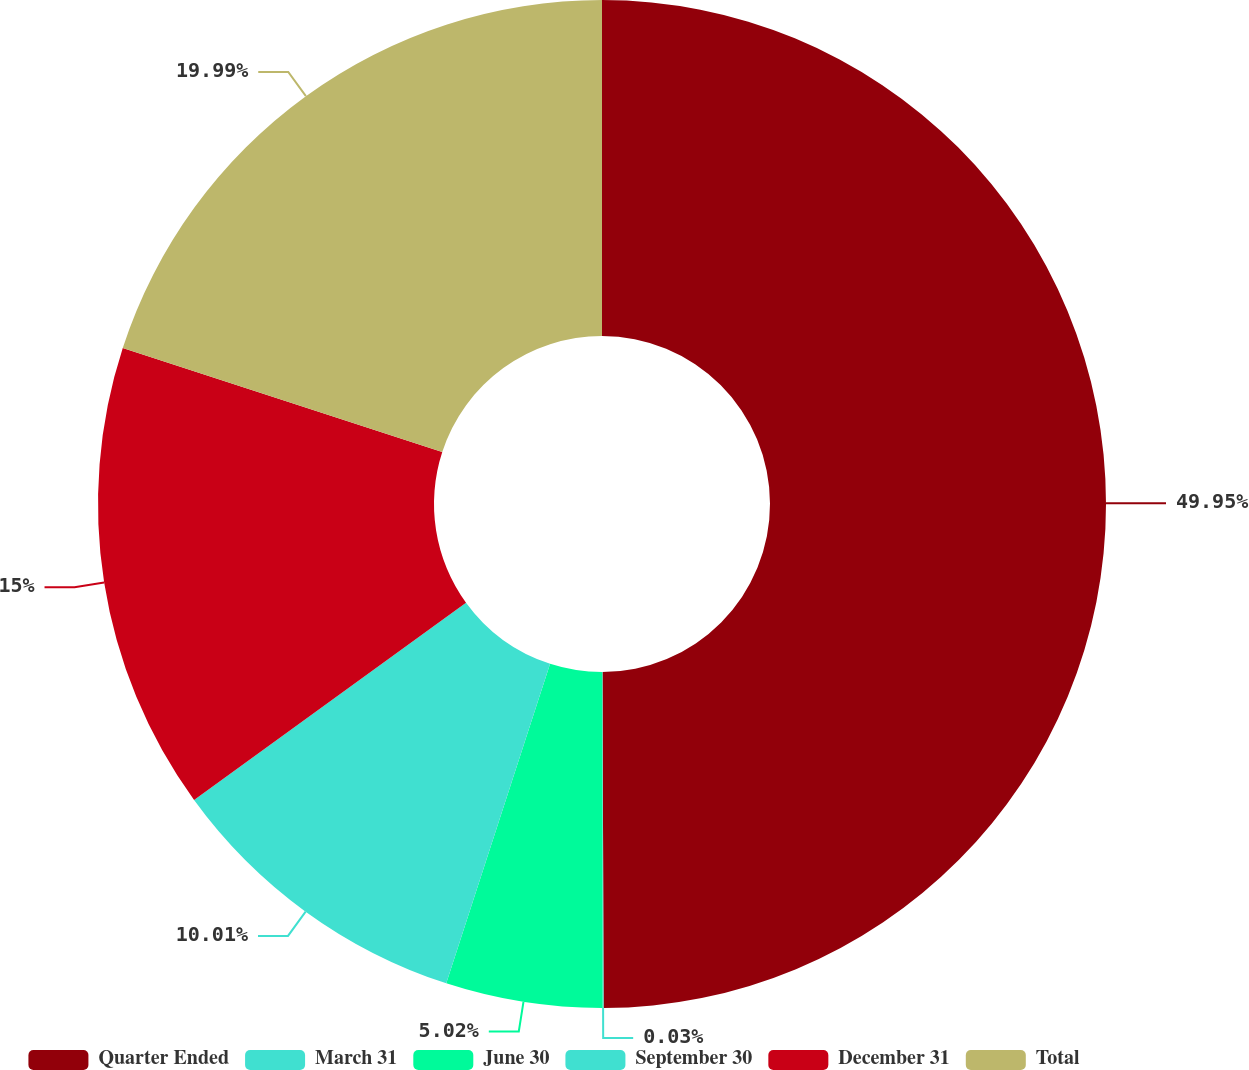Convert chart to OTSL. <chart><loc_0><loc_0><loc_500><loc_500><pie_chart><fcel>Quarter Ended<fcel>March 31<fcel>June 30<fcel>September 30<fcel>December 31<fcel>Total<nl><fcel>49.95%<fcel>0.03%<fcel>5.02%<fcel>10.01%<fcel>15.0%<fcel>19.99%<nl></chart> 